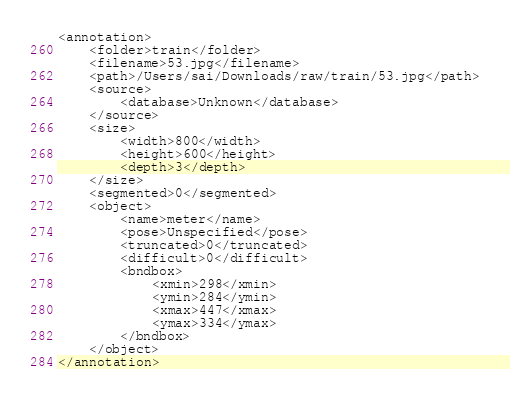<code> <loc_0><loc_0><loc_500><loc_500><_XML_><annotation>
	<folder>train</folder>
	<filename>53.jpg</filename>
	<path>/Users/sai/Downloads/raw/train/53.jpg</path>
	<source>
		<database>Unknown</database>
	</source>
	<size>
		<width>800</width>
		<height>600</height>
		<depth>3</depth>
	</size>
	<segmented>0</segmented>
	<object>
		<name>meter</name>
		<pose>Unspecified</pose>
		<truncated>0</truncated>
		<difficult>0</difficult>
		<bndbox>
			<xmin>298</xmin>
			<ymin>284</ymin>
			<xmax>447</xmax>
			<ymax>334</ymax>
		</bndbox>
	</object>
</annotation>
</code> 